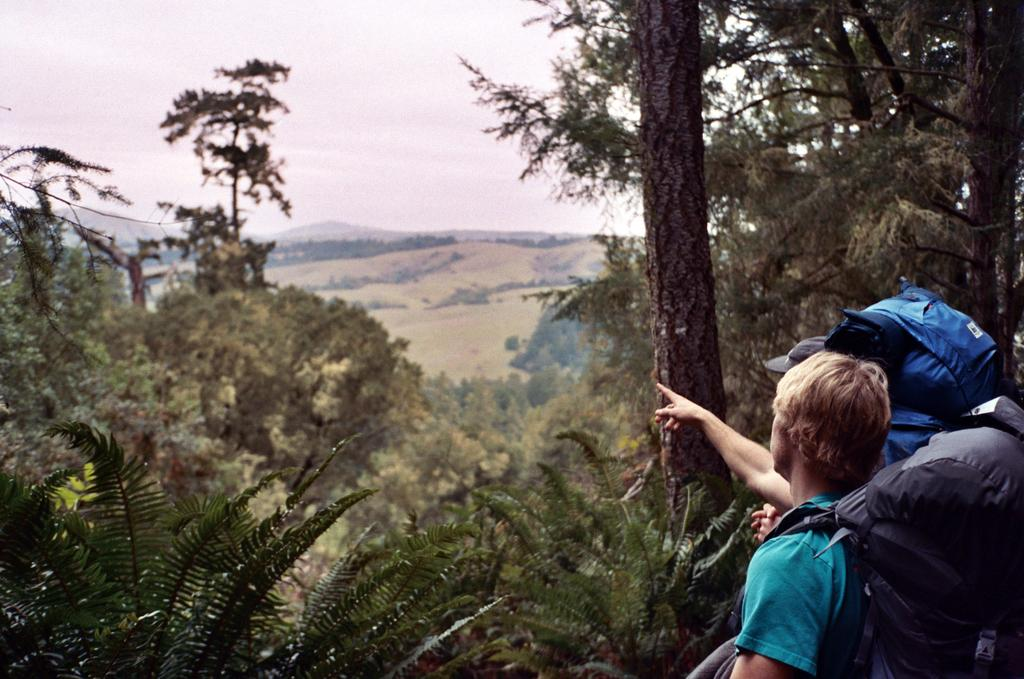How many people are in the image? There are two people in the image. What are the people doing in the image? The people are standing. What are the people wearing on their backs? The people are wearing backpacks. What can be seen in the background of the image? There are trees and hills in the background of the image. What type of ring can be seen on the person's finger in the image? There is no ring visible on any person's finger in the image. Can you tell me how the person is kicking a ball in the image? There is no person kicking a ball in the image; the people are standing with backpacks. 